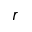Convert formula to latex. <formula><loc_0><loc_0><loc_500><loc_500>\boldsymbol r</formula> 